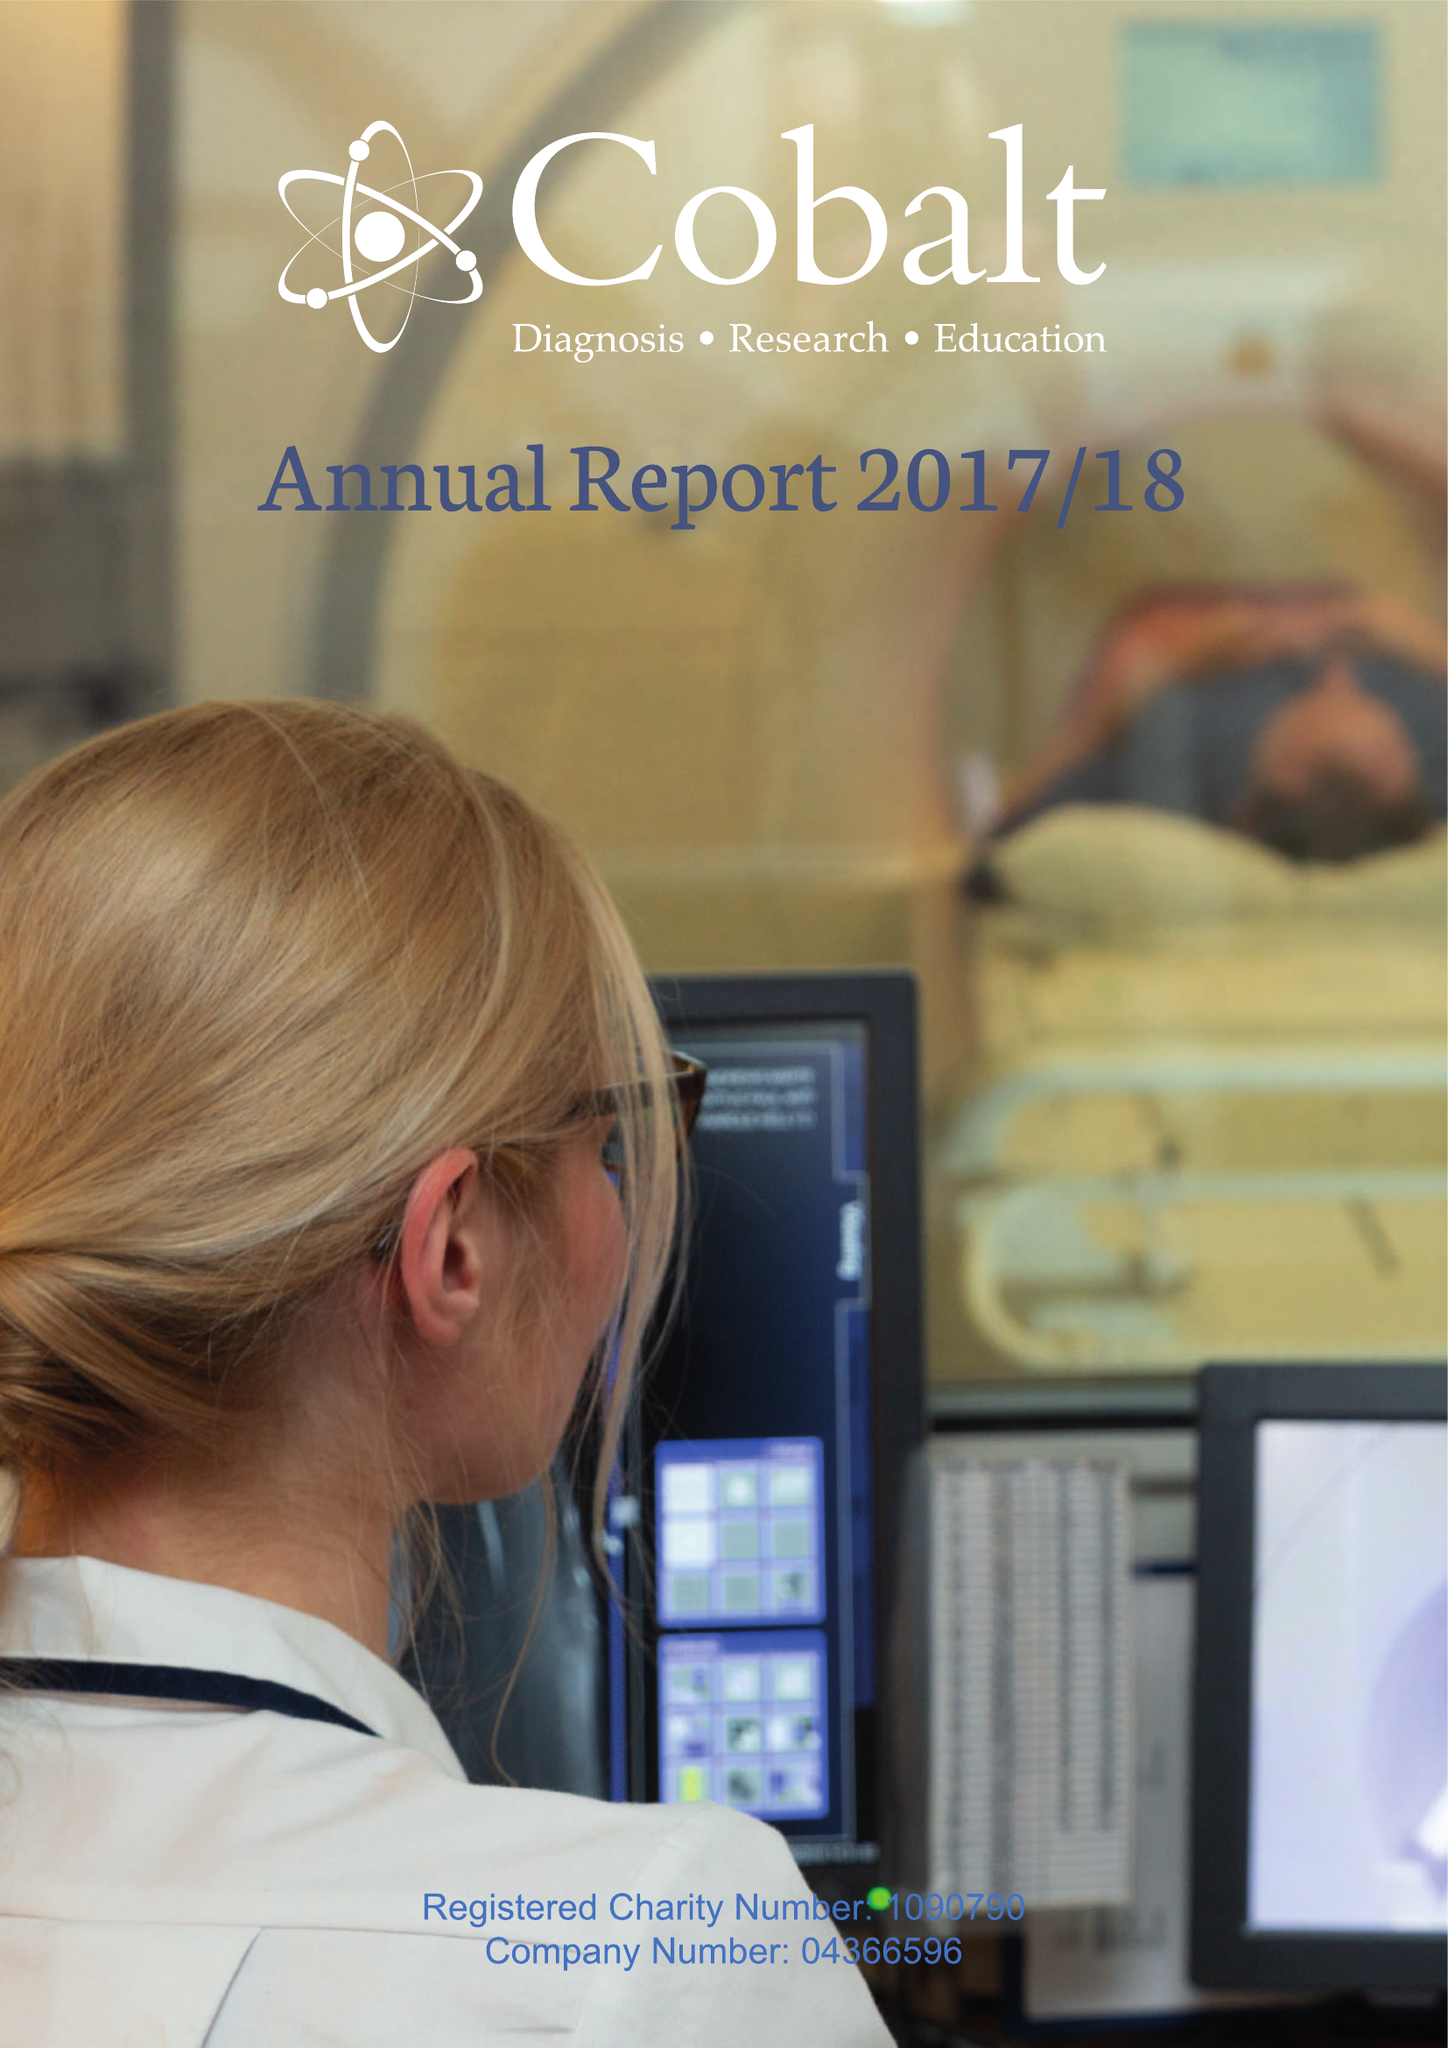What is the value for the address__postcode?
Answer the question using a single word or phrase. GL53 7AS 